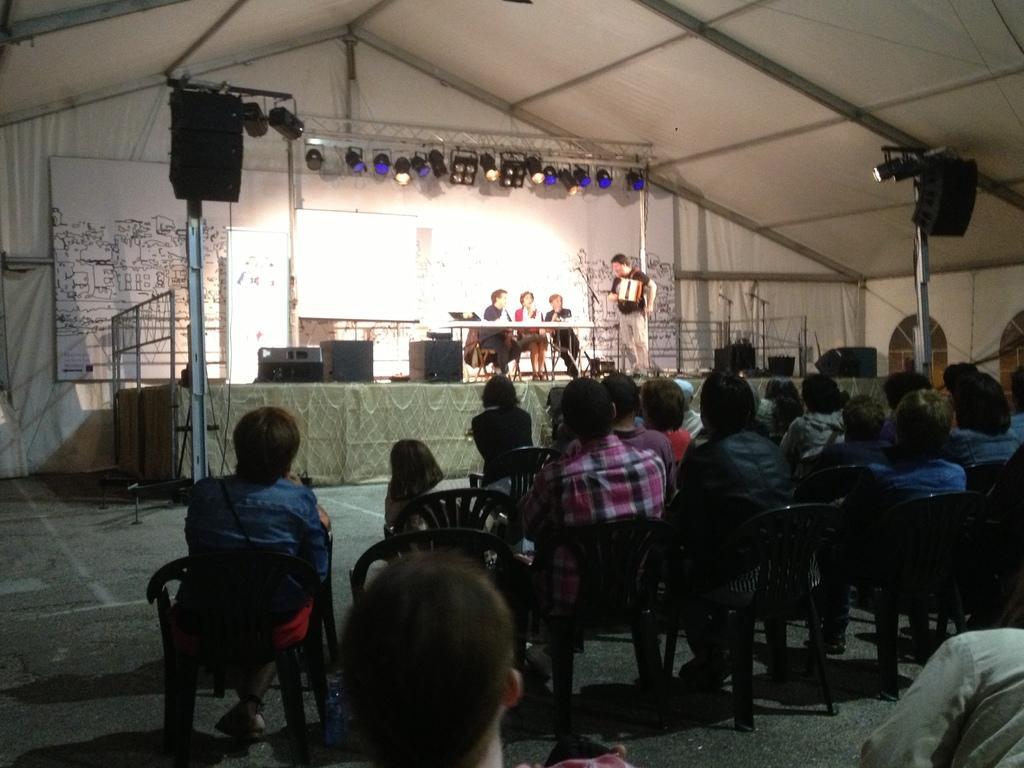In one or two sentences, can you explain what this image depicts? In this image I can see group of people sitting. In the background I can see the tent in white color and I can also see few lights. 